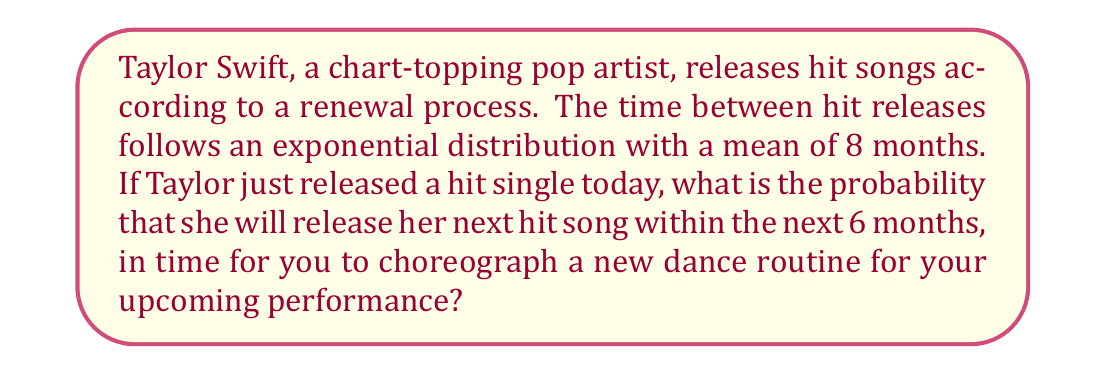Solve this math problem. Let's approach this step-by-step:

1) In a renewal process where the inter-arrival times follow an exponential distribution, the waiting time until the next event (in this case, the next hit song) also follows an exponential distribution.

2) We are given that the mean time between hit releases is 8 months. For an exponential distribution, the mean is equal to $\frac{1}{\lambda}$, where $\lambda$ is the rate parameter. So:

   $$\frac{1}{\lambda} = 8$$
   $$\lambda = \frac{1}{8}$$

3) The probability density function (PDF) of an exponential distribution is:

   $$f(x) = \lambda e^{-\lambda x}$$

4) To find the probability that the next hit will be released within 6 months, we need to integrate the PDF from 0 to 6:

   $$P(X \leq 6) = \int_0^6 \lambda e^{-\lambda x} dx$$

5) Substituting $\lambda = \frac{1}{8}$:

   $$P(X \leq 6) = \int_0^6 \frac{1}{8} e^{-\frac{1}{8} x} dx$$

6) Solving this integral:

   $$P(X \leq 6) = [-e^{-\frac{1}{8} x}]_0^6 = -e^{-\frac{6}{8}} - (-e^0) = 1 - e^{-\frac{3}{4}}$$

7) Calculate the final value:

   $$P(X \leq 6) = 1 - e^{-0.75} \approx 0.5276$$
Answer: $0.5276$ or $52.76\%$ 